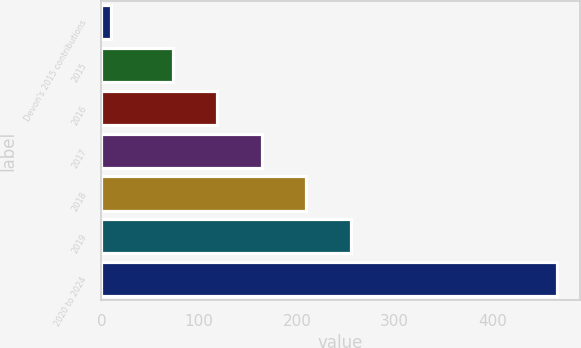Convert chart to OTSL. <chart><loc_0><loc_0><loc_500><loc_500><bar_chart><fcel>Devon's 2015 contributions<fcel>2015<fcel>2016<fcel>2017<fcel>2018<fcel>2019<fcel>2020 to 2024<nl><fcel>10<fcel>73<fcel>118.6<fcel>164.2<fcel>209.8<fcel>255.4<fcel>466<nl></chart> 